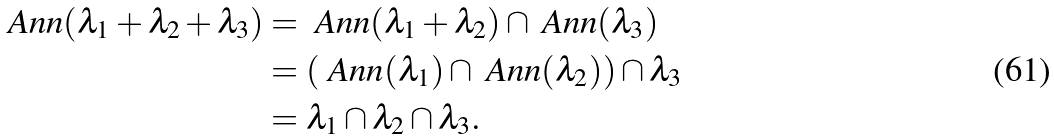<formula> <loc_0><loc_0><loc_500><loc_500>\ A n n ( \lambda _ { 1 } + \lambda _ { 2 } + \lambda _ { 3 } ) & = \ A n n ( \lambda _ { 1 } + \lambda _ { 2 } ) \cap \ A n n ( \lambda _ { 3 } ) \\ & = ( \ A n n ( \lambda _ { 1 } ) \cap \ A n n ( \lambda _ { 2 } ) ) \cap \lambda _ { 3 } \\ & = \lambda _ { 1 } \cap \lambda _ { 2 } \cap \lambda _ { 3 } .</formula> 